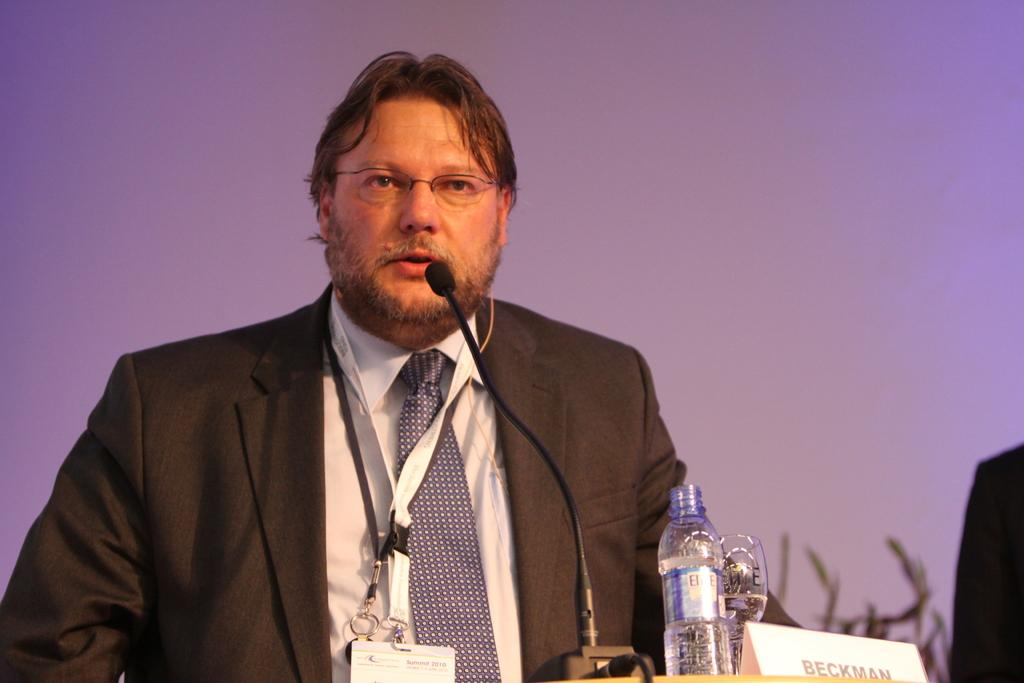What is the man in the image wearing? The man is wearing a blazer, a tie, and spectacles. What is the man doing in the image? The man is talking on a microphone. What is in front of the man? There is a bottle and a name board in front of the man. What can be seen in the background of the image? There is a wall in the background of the image. What type of oatmeal is being served in the image? There is no oatmeal present in the image. Is the volcano erupting in the image? There is no volcano present in the image. 